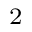<formula> <loc_0><loc_0><loc_500><loc_500>^ { 2 }</formula> 